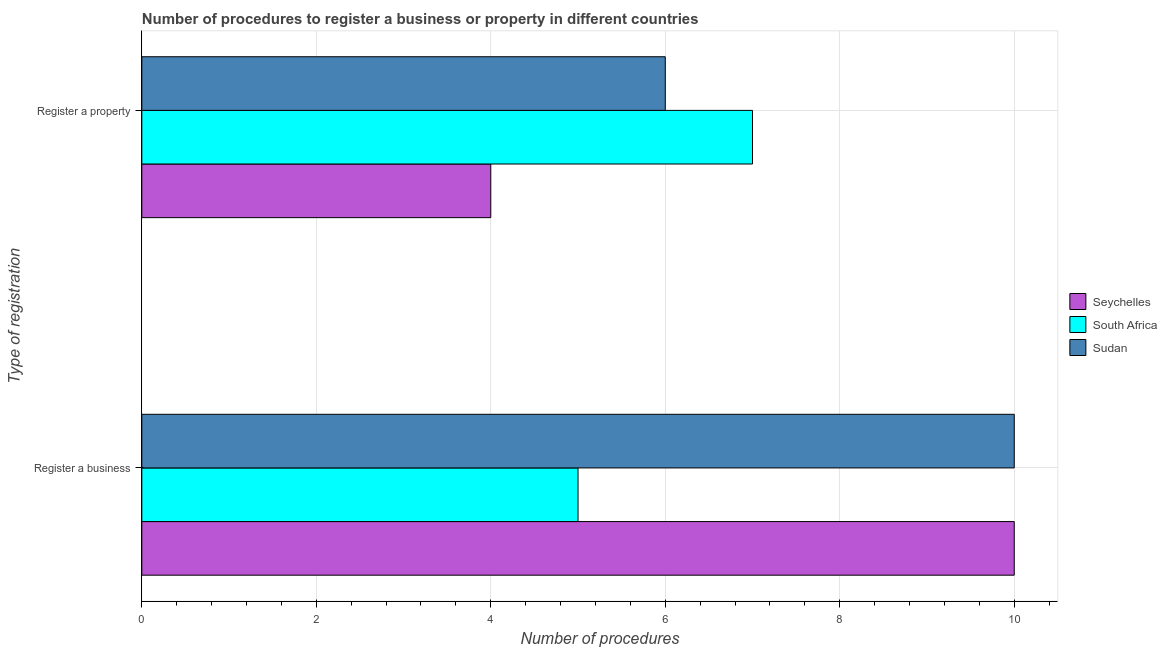How many groups of bars are there?
Your answer should be compact. 2. How many bars are there on the 2nd tick from the top?
Offer a terse response. 3. What is the label of the 1st group of bars from the top?
Give a very brief answer. Register a property. What is the number of procedures to register a business in South Africa?
Offer a terse response. 5. Across all countries, what is the maximum number of procedures to register a business?
Ensure brevity in your answer.  10. Across all countries, what is the minimum number of procedures to register a business?
Keep it short and to the point. 5. In which country was the number of procedures to register a business maximum?
Your response must be concise. Seychelles. In which country was the number of procedures to register a business minimum?
Ensure brevity in your answer.  South Africa. What is the total number of procedures to register a property in the graph?
Make the answer very short. 17. What is the difference between the number of procedures to register a business in Seychelles and that in South Africa?
Provide a succinct answer. 5. What is the difference between the number of procedures to register a business in Sudan and the number of procedures to register a property in Seychelles?
Your response must be concise. 6. What is the average number of procedures to register a business per country?
Your answer should be very brief. 8.33. What is the difference between the number of procedures to register a property and number of procedures to register a business in South Africa?
Your answer should be very brief. 2. In how many countries, is the number of procedures to register a property greater than 1.2000000000000002 ?
Give a very brief answer. 3. What is the ratio of the number of procedures to register a business in Seychelles to that in Sudan?
Give a very brief answer. 1. In how many countries, is the number of procedures to register a property greater than the average number of procedures to register a property taken over all countries?
Your answer should be compact. 2. What does the 2nd bar from the top in Register a business represents?
Keep it short and to the point. South Africa. What does the 1st bar from the bottom in Register a business represents?
Make the answer very short. Seychelles. How many bars are there?
Provide a succinct answer. 6. What is the difference between two consecutive major ticks on the X-axis?
Give a very brief answer. 2. Does the graph contain any zero values?
Make the answer very short. No. Where does the legend appear in the graph?
Your answer should be compact. Center right. What is the title of the graph?
Give a very brief answer. Number of procedures to register a business or property in different countries. What is the label or title of the X-axis?
Make the answer very short. Number of procedures. What is the label or title of the Y-axis?
Ensure brevity in your answer.  Type of registration. What is the Number of procedures in Seychelles in Register a business?
Keep it short and to the point. 10. What is the Number of procedures in Sudan in Register a business?
Provide a short and direct response. 10. What is the Number of procedures of South Africa in Register a property?
Your answer should be very brief. 7. Across all Type of registration, what is the maximum Number of procedures of Seychelles?
Offer a terse response. 10. Across all Type of registration, what is the maximum Number of procedures of South Africa?
Your answer should be very brief. 7. Across all Type of registration, what is the maximum Number of procedures of Sudan?
Provide a succinct answer. 10. Across all Type of registration, what is the minimum Number of procedures in South Africa?
Provide a short and direct response. 5. Across all Type of registration, what is the minimum Number of procedures of Sudan?
Provide a short and direct response. 6. What is the difference between the Number of procedures of South Africa in Register a business and that in Register a property?
Ensure brevity in your answer.  -2. What is the difference between the Number of procedures of Seychelles in Register a business and the Number of procedures of South Africa in Register a property?
Offer a terse response. 3. What is the difference between the Number of procedures in South Africa in Register a business and the Number of procedures in Sudan in Register a property?
Your response must be concise. -1. What is the average Number of procedures of South Africa per Type of registration?
Make the answer very short. 6. What is the average Number of procedures in Sudan per Type of registration?
Give a very brief answer. 8. What is the difference between the Number of procedures in Seychelles and Number of procedures in Sudan in Register a business?
Your answer should be compact. 0. What is the difference between the Number of procedures of South Africa and Number of procedures of Sudan in Register a business?
Your answer should be compact. -5. What is the difference between the Number of procedures in Seychelles and Number of procedures in South Africa in Register a property?
Provide a succinct answer. -3. What is the difference between the Number of procedures in Seychelles and Number of procedures in Sudan in Register a property?
Offer a very short reply. -2. What is the difference between the highest and the second highest Number of procedures in Seychelles?
Offer a very short reply. 6. What is the difference between the highest and the second highest Number of procedures of Sudan?
Provide a short and direct response. 4. What is the difference between the highest and the lowest Number of procedures of South Africa?
Offer a terse response. 2. What is the difference between the highest and the lowest Number of procedures of Sudan?
Offer a very short reply. 4. 